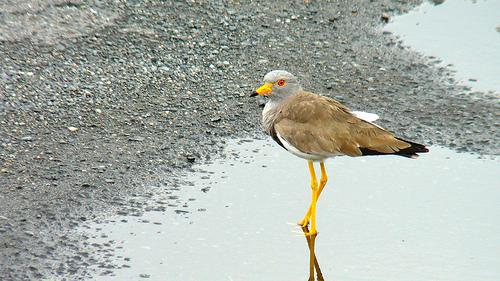Question: where was the picture taken?
Choices:
A. At my house.
B. On the beach.
C. On a plane.
D. On the couch.
Answer with the letter. Answer: B Question: when was the picture taken?
Choices:
A. In the morning.
B. Before sunset.
C. At noon.
D. Daytime.
Answer with the letter. Answer: D 